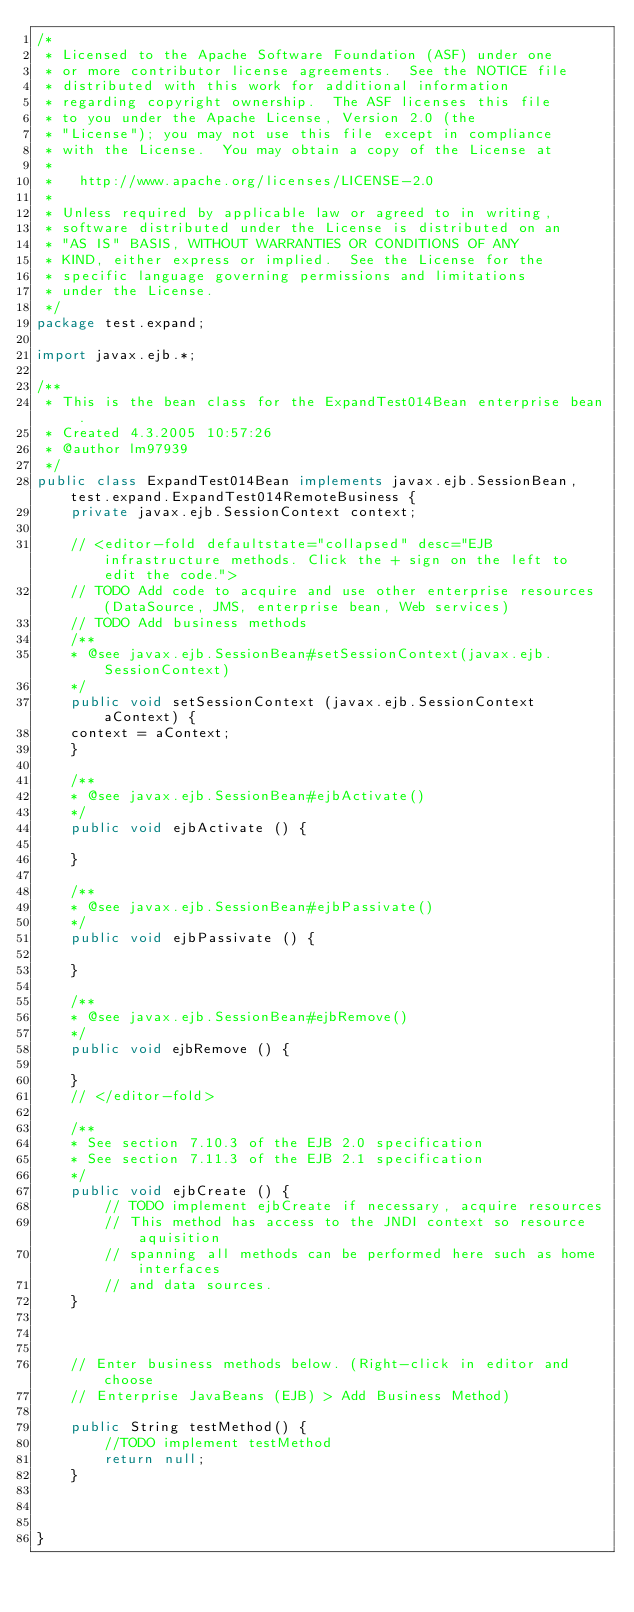<code> <loc_0><loc_0><loc_500><loc_500><_Java_>/*
 * Licensed to the Apache Software Foundation (ASF) under one
 * or more contributor license agreements.  See the NOTICE file
 * distributed with this work for additional information
 * regarding copyright ownership.  The ASF licenses this file
 * to you under the Apache License, Version 2.0 (the
 * "License"); you may not use this file except in compliance
 * with the License.  You may obtain a copy of the License at
 *
 *   http://www.apache.org/licenses/LICENSE-2.0
 *
 * Unless required by applicable law or agreed to in writing,
 * software distributed under the License is distributed on an
 * "AS IS" BASIS, WITHOUT WARRANTIES OR CONDITIONS OF ANY
 * KIND, either express or implied.  See the License for the
 * specific language governing permissions and limitations
 * under the License.
 */
package test.expand;
    
import javax.ejb.*;
  
/**
 * This is the bean class for the ExpandTest014Bean enterprise bean.
 * Created 4.3.2005 10:57:26
 * @author lm97939
 */
public class ExpandTest014Bean implements javax.ejb.SessionBean, test.expand.ExpandTest014RemoteBusiness {
    private javax.ejb.SessionContext context;

    // <editor-fold defaultstate="collapsed" desc="EJB infrastructure methods. Click the + sign on the left to edit the code.">
    // TODO Add code to acquire and use other enterprise resources (DataSource, JMS, enterprise bean, Web services)
    // TODO Add business methods
    /**
    * @see javax.ejb.SessionBean#setSessionContext(javax.ejb.SessionContext)
    */
    public void setSessionContext (javax.ejb.SessionContext aContext) {
    context = aContext;
    }

    /**
    * @see javax.ejb.SessionBean#ejbActivate()
    */
    public void ejbActivate () {

    }

    /**
    * @see javax.ejb.SessionBean#ejbPassivate()
    */
    public void ejbPassivate () {

    }

    /**
    * @see javax.ejb.SessionBean#ejbRemove()
    */
    public void ejbRemove () {

    }
    // </editor-fold>
    
    /**
    * See section 7.10.3 of the EJB 2.0 specification
    * See section 7.11.3 of the EJB 2.1 specification
    */
    public void ejbCreate () {
        // TODO implement ejbCreate if necessary, acquire resources
        // This method has access to the JNDI context so resource aquisition
        // spanning all methods can be performed here such as home interfaces
        // and data sources. 
    }
 
    

    // Enter business methods below. (Right-click in editor and choose 
    // Enterprise JavaBeans (EJB) > Add Business Method)

    public String testMethod() {
        //TODO implement testMethod
        return null;
    }
    

    
}
  
</code> 